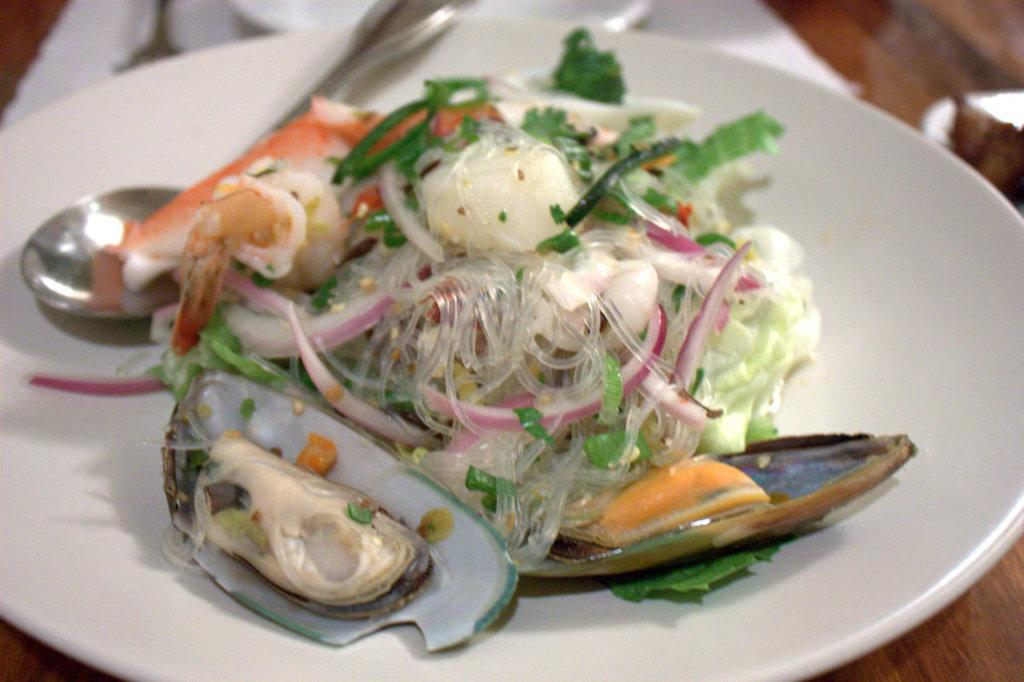What is on the plate that is visible in the image? There is food in a plate in the image. What utensil is present in the image? There is a spoon in the image. What might be used for cleaning or wiping in the image? Tissue papers are present in the image. What type of surface are the objects placed on in the image? There are objects on a wooden platform in the image. How does the deer interact with the stem in the image? There is no deer or stem present in the image. 